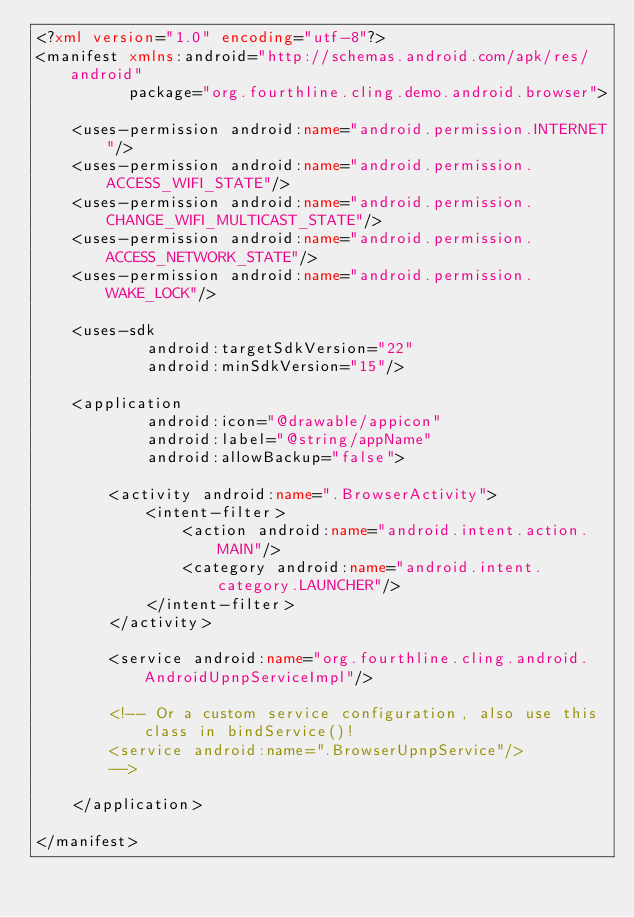<code> <loc_0><loc_0><loc_500><loc_500><_XML_><?xml version="1.0" encoding="utf-8"?>
<manifest xmlns:android="http://schemas.android.com/apk/res/android"
          package="org.fourthline.cling.demo.android.browser">

    <uses-permission android:name="android.permission.INTERNET"/>
    <uses-permission android:name="android.permission.ACCESS_WIFI_STATE"/>
    <uses-permission android:name="android.permission.CHANGE_WIFI_MULTICAST_STATE"/>
    <uses-permission android:name="android.permission.ACCESS_NETWORK_STATE"/>
    <uses-permission android:name="android.permission.WAKE_LOCK"/>

    <uses-sdk
            android:targetSdkVersion="22"
            android:minSdkVersion="15"/>

    <application
            android:icon="@drawable/appicon"
            android:label="@string/appName"
            android:allowBackup="false">

        <activity android:name=".BrowserActivity">
            <intent-filter>
                <action android:name="android.intent.action.MAIN"/>
                <category android:name="android.intent.category.LAUNCHER"/>
            </intent-filter>
        </activity>

        <service android:name="org.fourthline.cling.android.AndroidUpnpServiceImpl"/>

        <!-- Or a custom service configuration, also use this class in bindService()!
        <service android:name=".BrowserUpnpService"/>
        -->

    </application>

</manifest>
</code> 